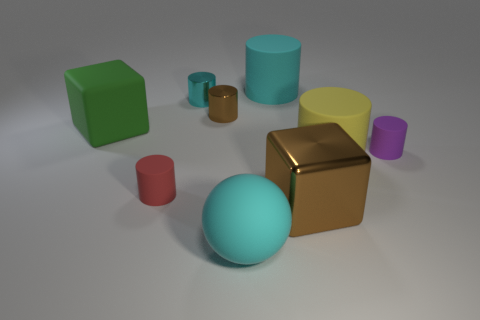Subtract all small purple matte cylinders. How many cylinders are left? 5 Subtract 1 cylinders. How many cylinders are left? 5 Add 6 large gray metallic balls. How many large gray metallic balls exist? 6 Add 1 purple cylinders. How many objects exist? 10 Subtract all brown cylinders. How many cylinders are left? 5 Subtract 1 green blocks. How many objects are left? 8 Subtract all cylinders. How many objects are left? 3 Subtract all yellow cylinders. Subtract all green cubes. How many cylinders are left? 5 Subtract all yellow blocks. How many red cylinders are left? 1 Subtract all large yellow cylinders. Subtract all cyan shiny cylinders. How many objects are left? 7 